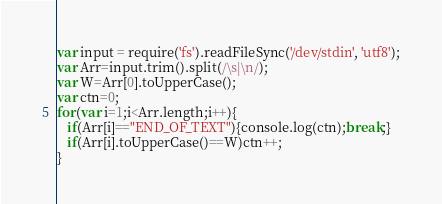<code> <loc_0><loc_0><loc_500><loc_500><_JavaScript_>var input = require('fs').readFileSync('/dev/stdin', 'utf8');
var Arr=input.trim().split(/\s|\n/);
var W=Arr[0].toUpperCase();
var ctn=0;
for(var i=1;i<Arr.length;i++){
   if(Arr[i]=="END_OF_TEXT"){console.log(ctn);break;}
   if(Arr[i].toUpperCase()==W)ctn++;
}</code> 